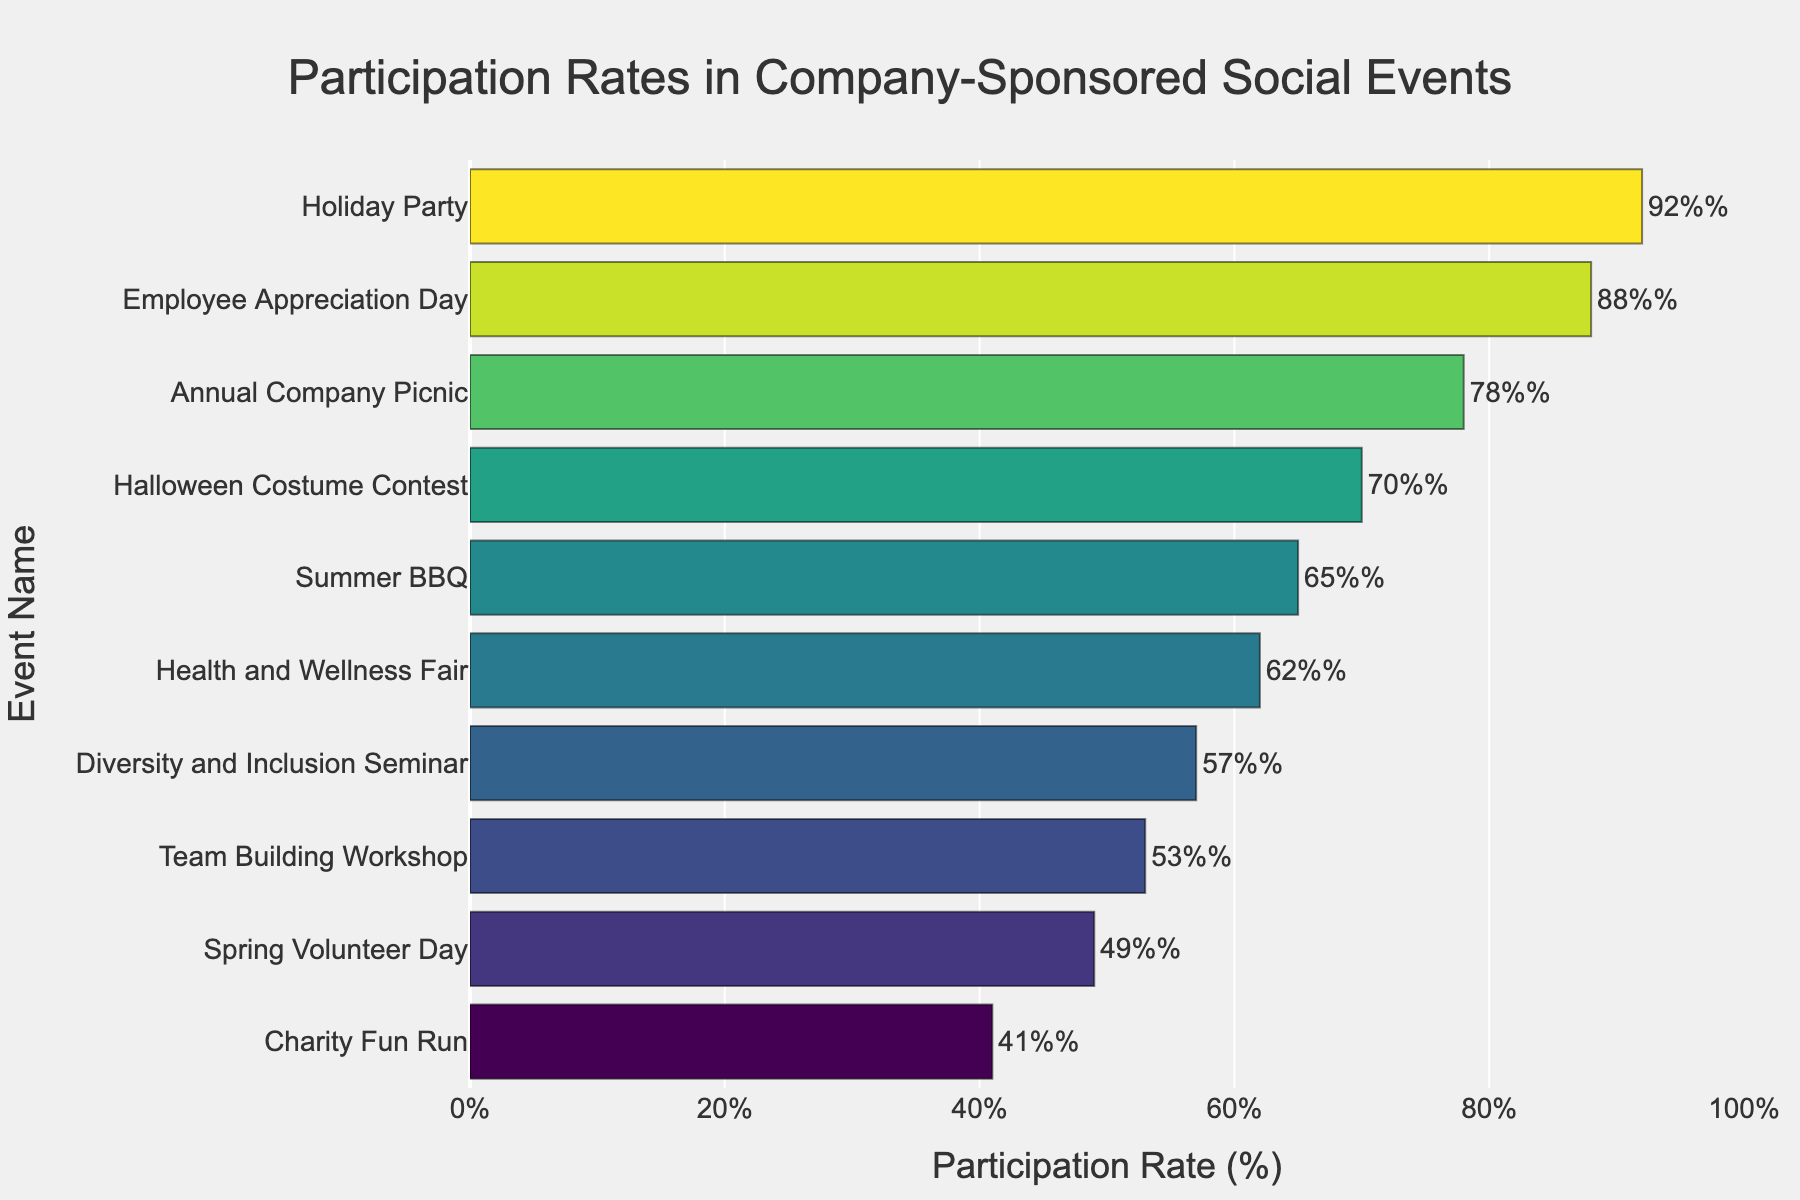What's the participation rate for the Annual Company Picnic? To find the participation rate for the "Annual Company Picnic," look at the bar labeled "Annual Company Picnic" and read the percentage value at the end of the bar.
Answer: 78% Which event had the highest participation rate? To determine the event with the highest participation rate, identify the longest bar on the chart.
Answer: Holiday Party Compare the participation rates between the Summer BBQ and the Health and Wellness Fair. Which one had a higher rate? Look at the bars for "Summer BBQ" and "Health and Wellness Fair" and compare their lengths. The bar for "Summer BBQ" ends at 65%, while the bar for "Health and Wellness Fair" ends at 62%.
Answer: Summer BBQ What is the total participation rate for all events combined? Add up all the participation rates from the dataset: 78 + 92 + 65 + 53 + 41 + 70 + 88 + 49 + 57 + 62 = 655%.
Answer: 655% What is the median participation rate of the events? First, list all participation rates in ascending order: 41, 49, 53, 57, 62, 65, 70, 78, 88, 92. Since there are 10 events, the median is the average of the 5th and 6th values: (62 + 65)/2 = 63.5%.
Answer: 63.5% Which event has a lower participation rate, the Charity Fun Run or the Diversity and Inclusion Seminar? Compare the lengths of the bars for "Charity Fun Run" and "Diversity and Inclusion Seminar." The bar for "Charity Fun Run" ends at 41%, while the bar for "Diversity and Inclusion Seminar" ends at 57%.
Answer: Charity Fun Run What is the difference in participation rates between Employee Appreciation Day and Spring Volunteer Day? Subtract the participation rate of "Spring Volunteer Day" from "Employee Appreciation Day": 88 - 49 = 39%.
Answer: 39% Among the listed events, how many have a participation rate above 60%? Identify all events with bars ending above the 60% mark: Holiday Party (92%), Employee Appreciation Day (88%), Annual Company Picnic (78%), Halloween Costume Contest (70%), Summer BBQ (65%), Health and Wellness Fair (62%). Count them.
Answer: 6 What is the average participation rate of the top three events? Identify the top three events: Holiday Party (92%), Employee Appreciation Day (88%), Annual Company Picnic (78%). Calculate the average: (92 + 88 + 78) / 3 = 86%.
Answer: 86% Which event had the least participation, and what was the rate? Identify the shortest bar on the chart.
Answer: Charity Fun Run, 41% 